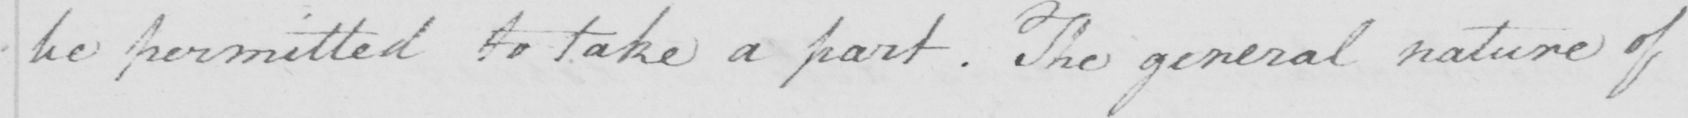Can you read and transcribe this handwriting? be permitted to take a part . The general nature of 